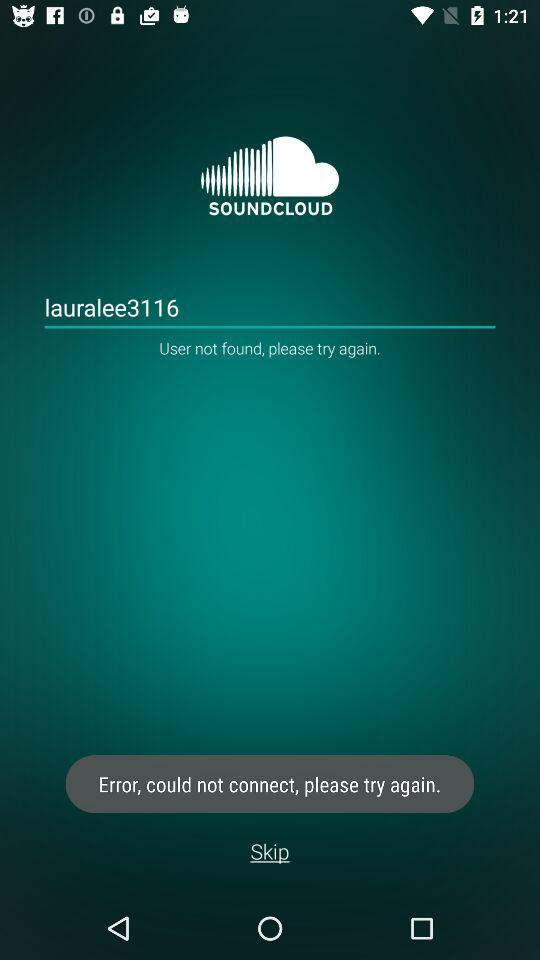What is the user name? The user name is "lauralee3116". 